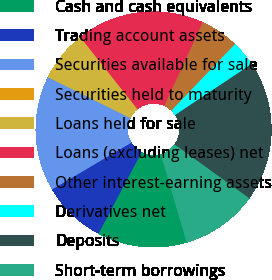Convert chart. <chart><loc_0><loc_0><loc_500><loc_500><pie_chart><fcel>Cash and cash equivalents<fcel>Trading account assets<fcel>Securities available for sale<fcel>Securities held to maturity<fcel>Loans held for sale<fcel>Loans (excluding leases) net<fcel>Other interest-earning assets<fcel>Derivatives net<fcel>Deposits<fcel>Short-term borrowings<nl><fcel>12.28%<fcel>8.77%<fcel>15.79%<fcel>0.01%<fcel>7.02%<fcel>17.54%<fcel>5.27%<fcel>3.51%<fcel>19.29%<fcel>10.53%<nl></chart> 